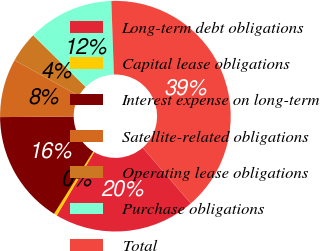Convert chart. <chart><loc_0><loc_0><loc_500><loc_500><pie_chart><fcel>Long-term debt obligations<fcel>Capital lease obligations<fcel>Interest expense on long-term<fcel>Satellite-related obligations<fcel>Operating lease obligations<fcel>Purchase obligations<fcel>Total<nl><fcel>19.83%<fcel>0.44%<fcel>15.95%<fcel>8.19%<fcel>4.31%<fcel>12.07%<fcel>39.22%<nl></chart> 